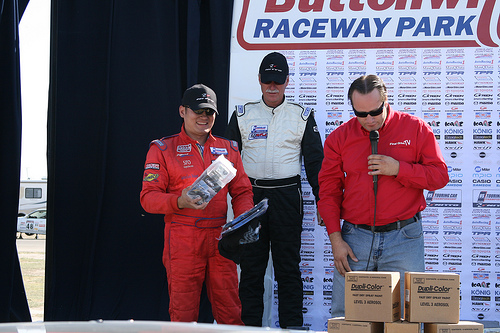<image>
Can you confirm if the man is in front of the man? No. The man is not in front of the man. The spatial positioning shows a different relationship between these objects. 